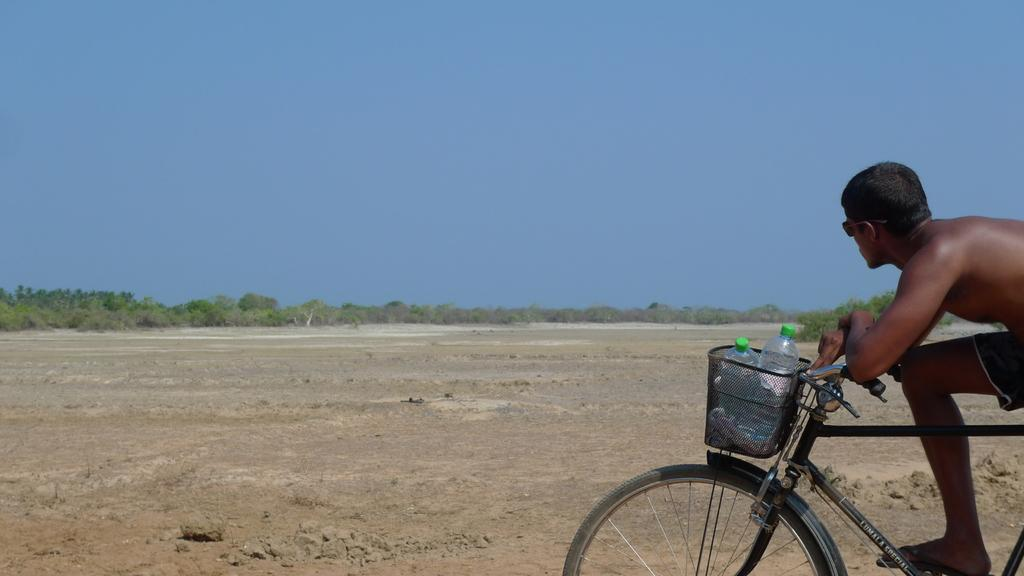Who is the person in the image? There is a man in the image. What is the man doing in the image? The man is on a bicycle. What items can be seen in the basket on the bicycle? There are two bottles in a basket on the bicycle. What can be seen in the background of the image? There is a tree and the sky visible in the background of the image. How much straw is the man using to cook in the image? There is no straw or cooking activity present in the image. What type of cookware is the man using to prepare a meal in the image? There is no cookware or cooking activity present in the image. 